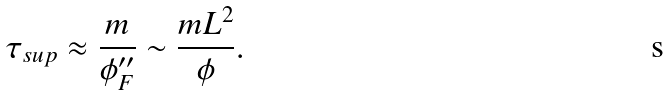<formula> <loc_0><loc_0><loc_500><loc_500>\tau _ { s u p } \approx \frac { m } { \phi _ { F } ^ { \prime \prime } } \sim \frac { m L ^ { 2 } } { \phi } .</formula> 